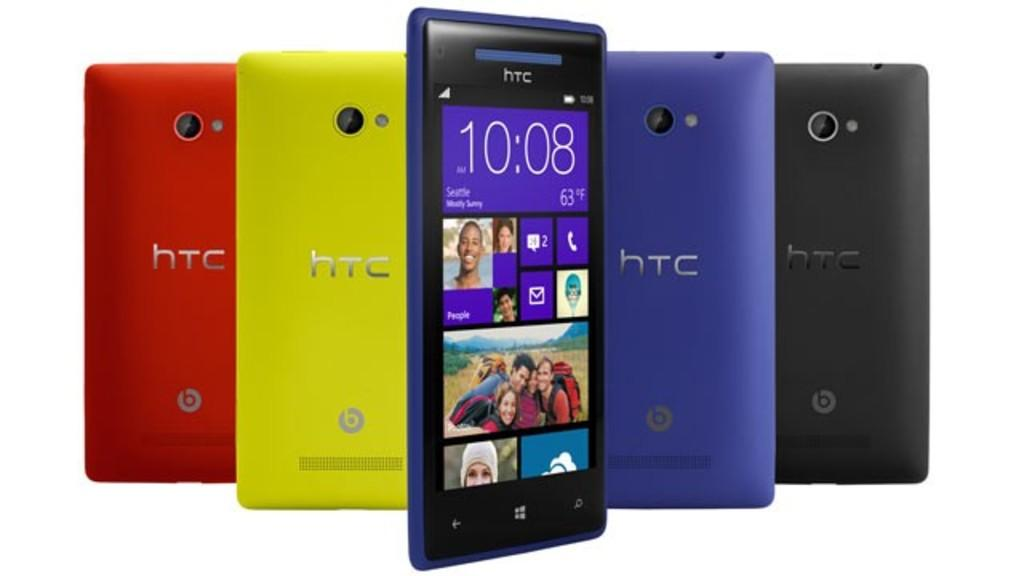<image>
Present a compact description of the photo's key features. A row of phones that say HTC on the back and are red, yellow, blue and black. 